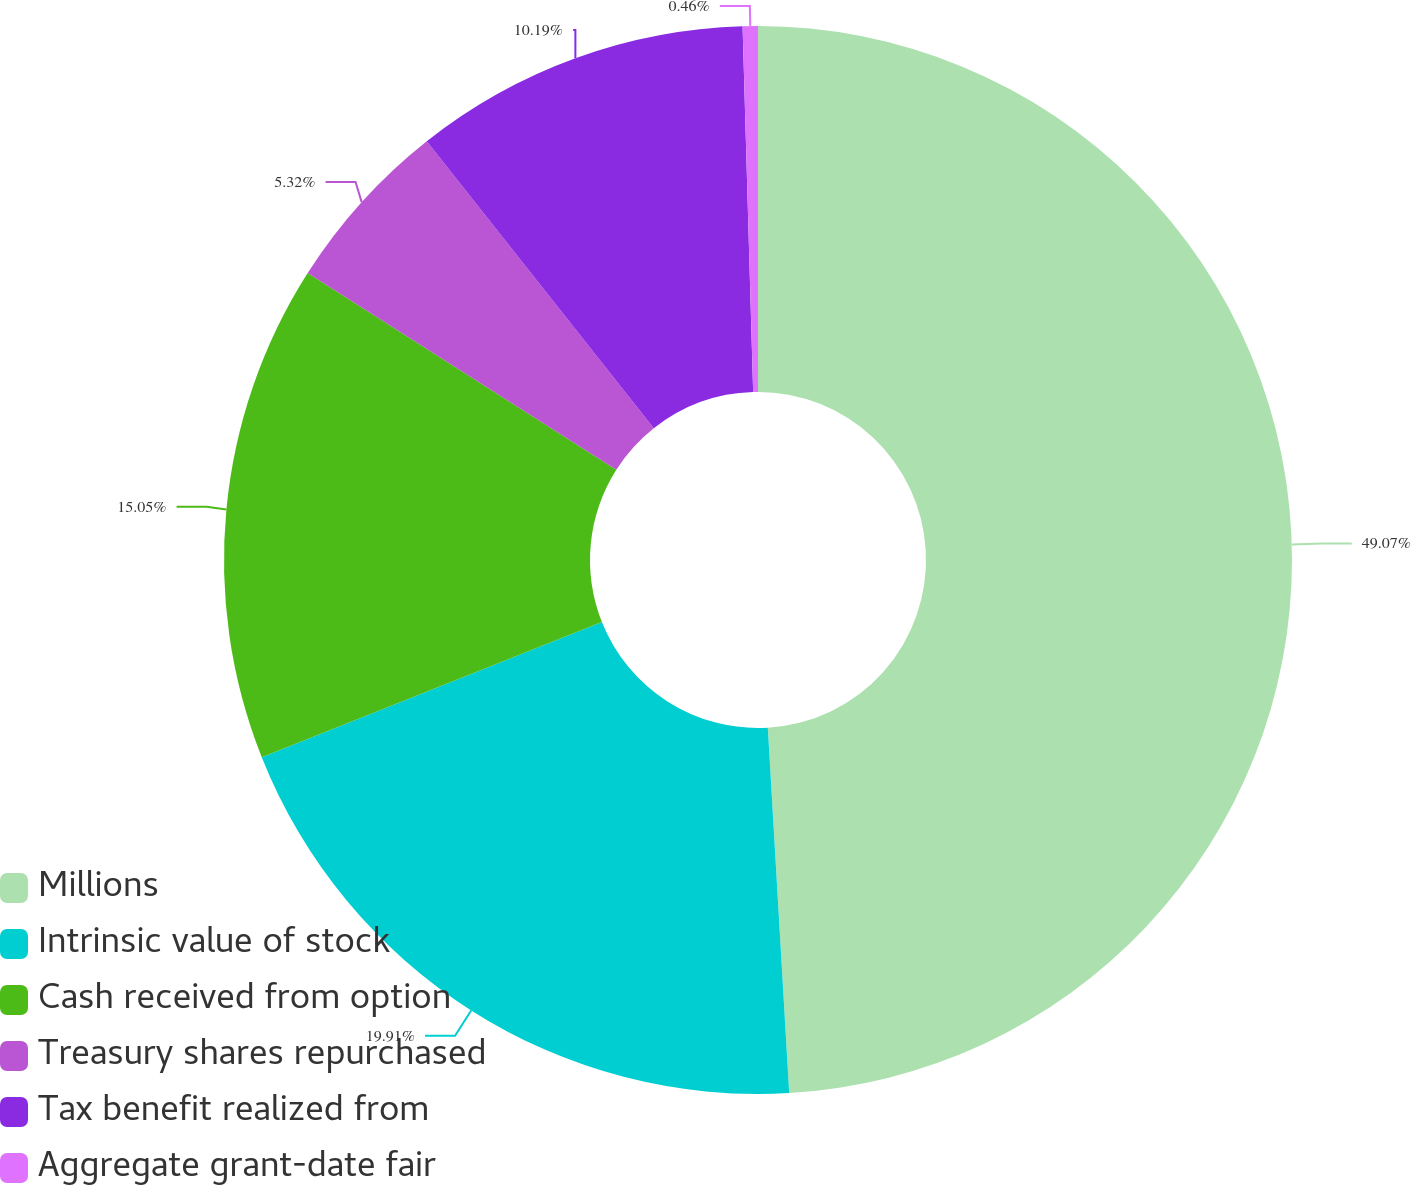<chart> <loc_0><loc_0><loc_500><loc_500><pie_chart><fcel>Millions<fcel>Intrinsic value of stock<fcel>Cash received from option<fcel>Treasury shares repurchased<fcel>Tax benefit realized from<fcel>Aggregate grant-date fair<nl><fcel>49.07%<fcel>19.91%<fcel>15.05%<fcel>5.32%<fcel>10.19%<fcel>0.46%<nl></chart> 